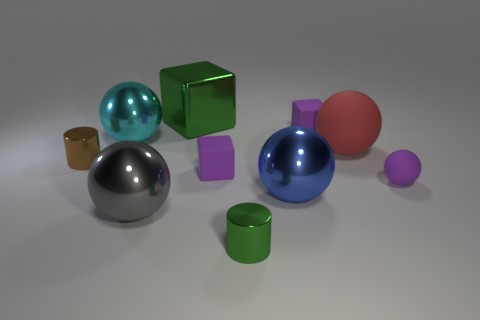Subtract all large blue spheres. How many spheres are left? 4 Subtract all blue cylinders. How many purple blocks are left? 2 Subtract all blue balls. How many balls are left? 4 Subtract 1 gray spheres. How many objects are left? 9 Subtract all cylinders. How many objects are left? 8 Subtract all red spheres. Subtract all cyan cylinders. How many spheres are left? 4 Subtract all brown shiny things. Subtract all purple matte balls. How many objects are left? 8 Add 2 large blue metallic objects. How many large blue metallic objects are left? 3 Add 2 tiny red shiny things. How many tiny red shiny things exist? 2 